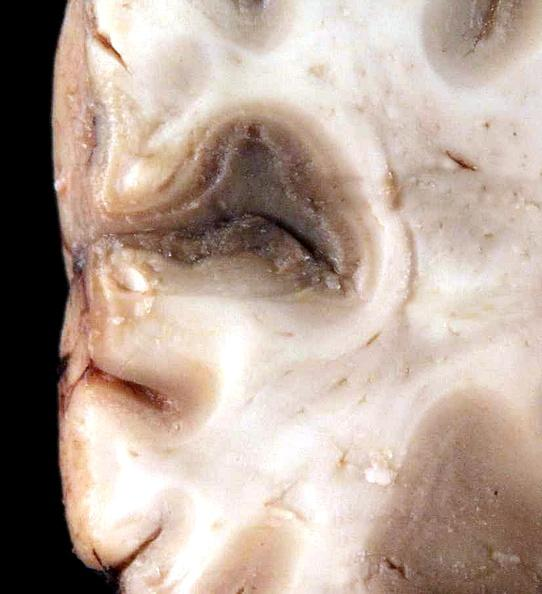does schwannoma show brain, cryptococcal meningitis?
Answer the question using a single word or phrase. No 